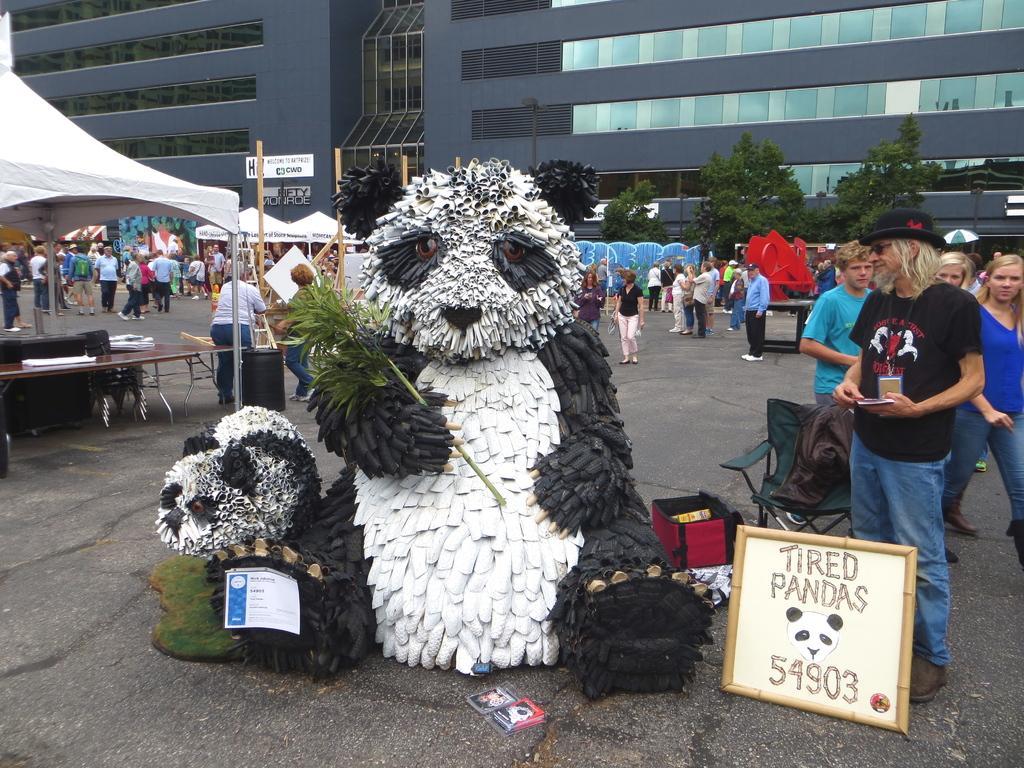Describe this image in one or two sentences. In this picture we can see one big building in front some people are standing, there are few stakes arranged and also one teddy. 